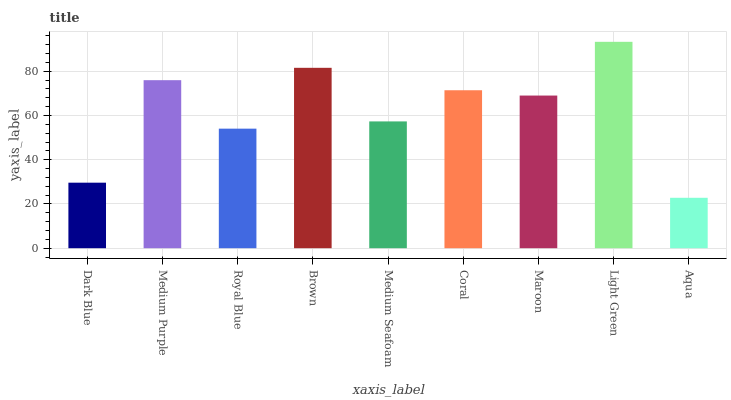Is Aqua the minimum?
Answer yes or no. Yes. Is Light Green the maximum?
Answer yes or no. Yes. Is Medium Purple the minimum?
Answer yes or no. No. Is Medium Purple the maximum?
Answer yes or no. No. Is Medium Purple greater than Dark Blue?
Answer yes or no. Yes. Is Dark Blue less than Medium Purple?
Answer yes or no. Yes. Is Dark Blue greater than Medium Purple?
Answer yes or no. No. Is Medium Purple less than Dark Blue?
Answer yes or no. No. Is Maroon the high median?
Answer yes or no. Yes. Is Maroon the low median?
Answer yes or no. Yes. Is Aqua the high median?
Answer yes or no. No. Is Coral the low median?
Answer yes or no. No. 